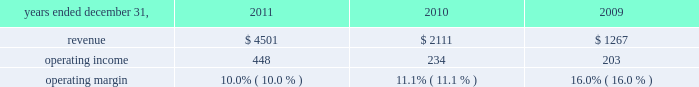Reinsurance commissions , fees and other revenue increased 1% ( 1 % ) driven by a favorable foreign currency translation of 2% ( 2 % ) and was partially offset by a 1% ( 1 % ) decline in dispositions , net of acquisitions and other .
Organic revenue was flat primarily resulting from strong growth in the capital market transactions and advisory business , partially offset by declines in global facultative placements .
Operating income operating income increased $ 120 million , or 10% ( 10 % ) , from 2010 to $ 1.3 billion in 2011 .
In 2011 , operating income margins in this segment were 19.3% ( 19.3 % ) , up 70 basis points from 18.6% ( 18.6 % ) in 2010 .
Operating margin improvement was primarily driven by revenue growth , reduced costs of restructuring initiatives and realization of the benefits of those restructuring plans , which was partially offset by the negative impact of expense increases related to investment in the business , lease termination costs , legacy receivables write-off , and foreign currency exchange rates .
Hr solutions .
In october 2010 , we completed the acquisition of hewitt , one of the world 2019s leading human resource consulting and outsourcing companies .
Hewitt operates globally together with aon 2019s existing consulting and outsourcing operations under the newly created aon hewitt brand .
Hewitt 2019s operating results are included in aon 2019s results of operations beginning october 1 , 2010 .
Our hr solutions segment generated approximately 40% ( 40 % ) of our consolidated total revenues in 2011 and provides a broad range of human capital services , as follows : 2022 health and benefits advises clients about how to structure , fund , and administer employee benefit programs that attract , retain , and motivate employees .
Benefits consulting includes health and welfare , executive benefits , workforce strategies and productivity , absence management , benefits administration , data-driven health , compliance , employee commitment , investment advisory and elective benefits services .
Effective january 1 , 2012 , this line of business will be included in the results of the risk solutions segment .
2022 retirement specializes in global actuarial services , defined contribution consulting , investment consulting , tax and erisa consulting , and pension administration .
2022 compensation focuses on compensatory advisory/counsel including : compensation planning design , executive reward strategies , salary survey and benchmarking , market share studies and sales force effectiveness , with special expertise in the financial services and technology industries .
2022 strategic human capital delivers advice to complex global organizations on talent , change and organizational effectiveness issues , including talent strategy and acquisition , executive on-boarding , performance management , leadership assessment and development , communication strategy , workforce training and change management .
2022 benefits administration applies our hr expertise primarily through defined benefit ( pension ) , defined contribution ( 401 ( k ) ) , and health and welfare administrative services .
Our model replaces the resource-intensive processes once required to administer benefit plans with more efficient , effective , and less costly solutions .
2022 human resource business processing outsourcing ( 2018 2018hr bpo 2019 2019 ) provides market-leading solutions to manage employee data ; administer benefits , payroll and other human resources processes ; and .
What was the percent of the increase in the revenue from 2010 to 2011? 
Rationale: the revenue increase 113% from 2010 to 2011
Computations: ((4501 - 2111) / 2111)
Answer: 1.13216. 